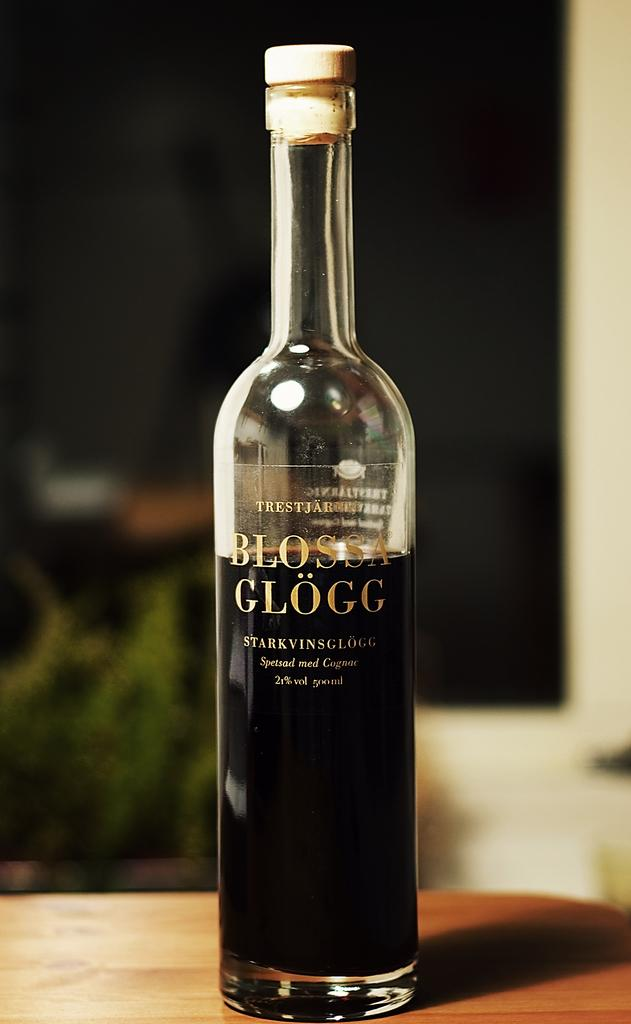What is the main object in the image? There is a wine bottle in the image. Where is the wine bottle located? The wine bottle is on a table. What type of decision can be made by looking at the wine bottle in the image? There is no decision-making process depicted in the image; it simply shows a wine bottle on a table. 